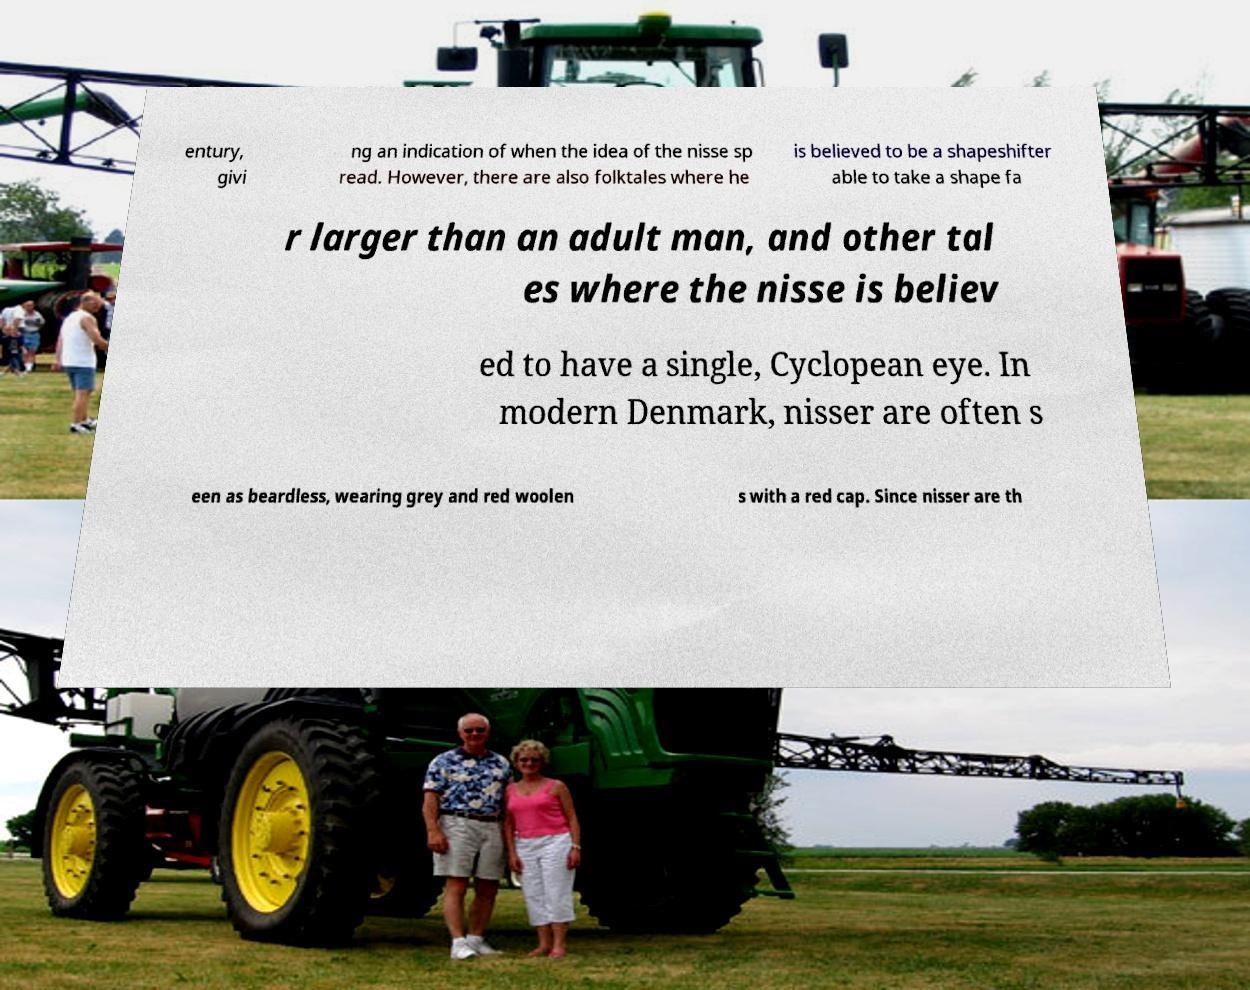Could you extract and type out the text from this image? entury, givi ng an indication of when the idea of the nisse sp read. However, there are also folktales where he is believed to be a shapeshifter able to take a shape fa r larger than an adult man, and other tal es where the nisse is believ ed to have a single, Cyclopean eye. In modern Denmark, nisser are often s een as beardless, wearing grey and red woolen s with a red cap. Since nisser are th 